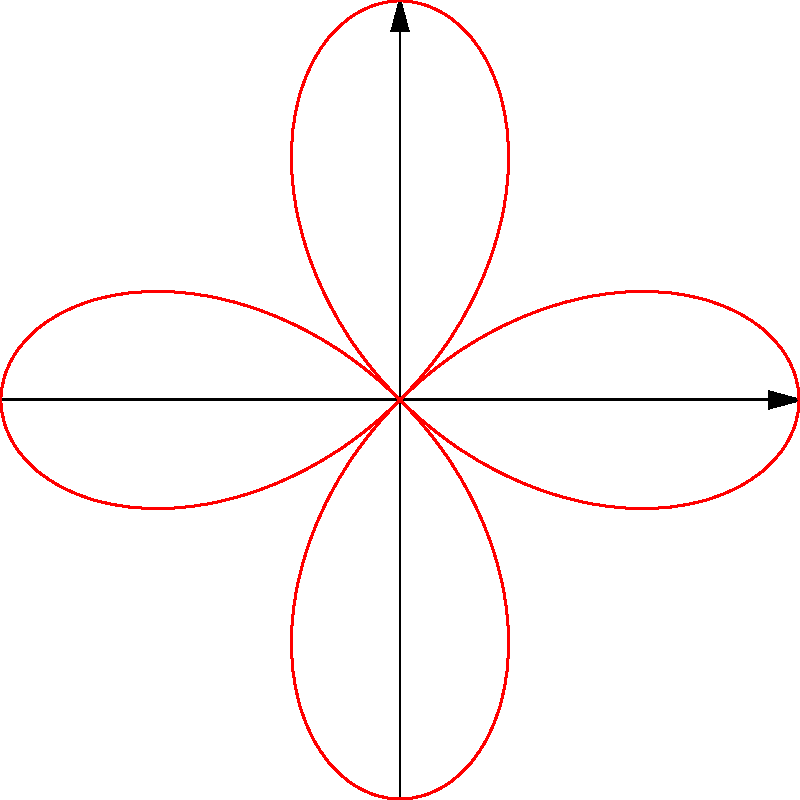Given the polar equation $r = \cos(2\theta)$, which represents a polar rose curve with 4 petals, what is the maximum value of $r$ in this curve? To find the maximum value of $r$ in this polar rose curve, let's follow these steps:

1) The equation is given as $r = \cos(2\theta)$.

2) We know that the cosine function has a range of [-1, 1], meaning its maximum value is 1 and its minimum value is -1.

3) In this case, $r$ is directly equal to $\cos(2\theta)$, so it will have the same range as the cosine function.

4) The maximum value of $r$ will occur when $\cos(2\theta)$ is at its maximum.

5) $\cos(2\theta)$ reaches its maximum value of 1 when $2\theta = 0, 2\pi, 4\pi,$ etc.

6) Therefore, the maximum value of $r$ in this polar rose curve is 1.

This maximum value corresponds to the distance from the origin to the tip of each petal in the four-petaled rose curve.
Answer: 1 